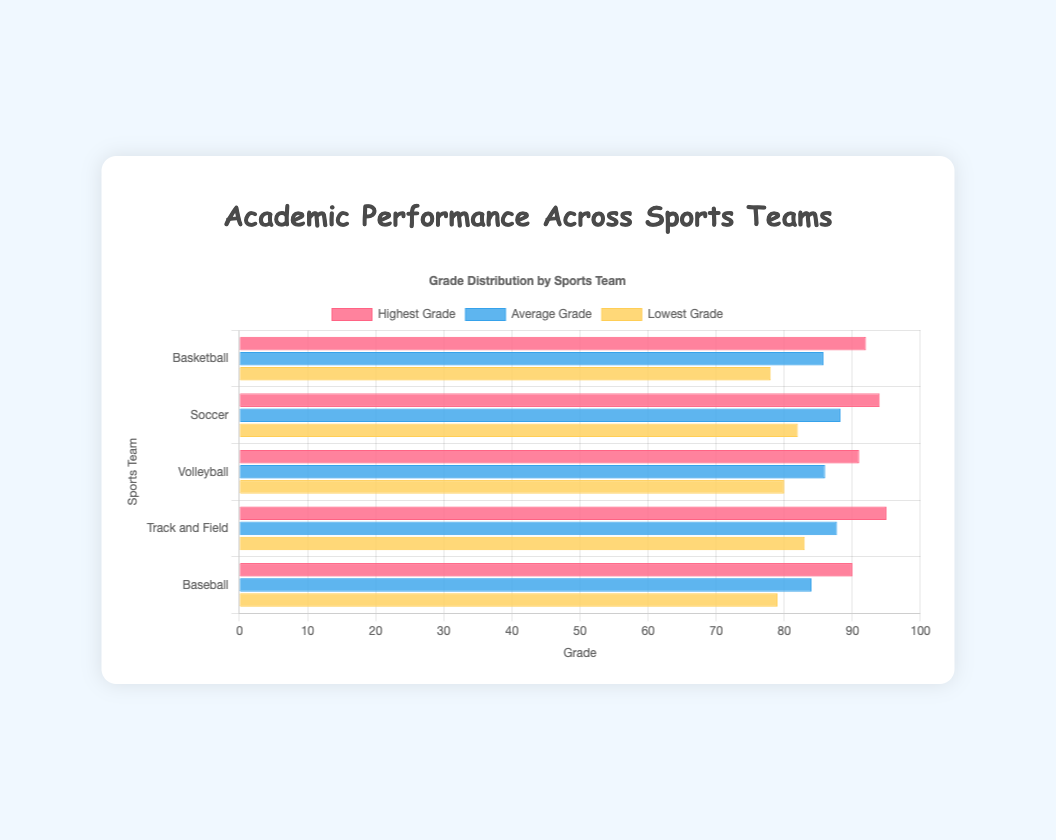What's the highest grade in the Volleyball team? Look at the "Highest Grade" bar for the Volleyball team. The length of the bar will indicate the highest grade, which is 91.
Answer: 91 Which team has the lowest average grade? Compare the "Average Grade" bars across all teams to find the shortest one. The shortest bar, representing the lowest average grade, is for the Baseball team.
Answer: Baseball Which team has the highest grade and what is that grade? Check the "Highest Grade" bars across all teams to see which one is the longest. The Track and Field team has the highest grade with a value of 95.
Answer: Track and Field, 95 What's the range of grades in the Soccer team? The range is calculated by subtracting the lowest grade from the highest grade in the Soccer team. The highest grade is 94 and the lowest grade is 82, so 94 - 82 = 12.
Answer: 12 Is there any team where the lowest grade is above 80? Find the "Lowest Grade" bars and see if any of them are over the 80 mark. The Soccer, Volleyball, and Track and Field teams all have their lowest grades above 80.
Answer: Yes How does the average grade of the Basketball team compare to the Baseball team? Compare the "Average Grade" bars for both the Basketball and Baseball teams. The Basketball team's average grade (85.75) is higher than the Baseball team's average grade (84).
Answer: Basketball higher What is the difference between the highest and lowest grades in the Basketball team? Look at the "Highest Grade" and "Lowest Grade" bars for the Basketball team. The highest grade is 92 and the lowest grade is 78, so 92 - 78 = 14.
Answer: 14 Which team has the closest average grade to 90? Find the "Average Grade" bars and identify the one closest to the 90 mark. The Volleyball team's average grade of 86 was closest to 90.
Answer: Volleyball What colors represent the highest, average, and lowest grades on the chart? Identify the colors used in the bars. The highest grade is red, the average grade is blue, and the lowest grade is yellow.
Answer: red, blue, yellow 